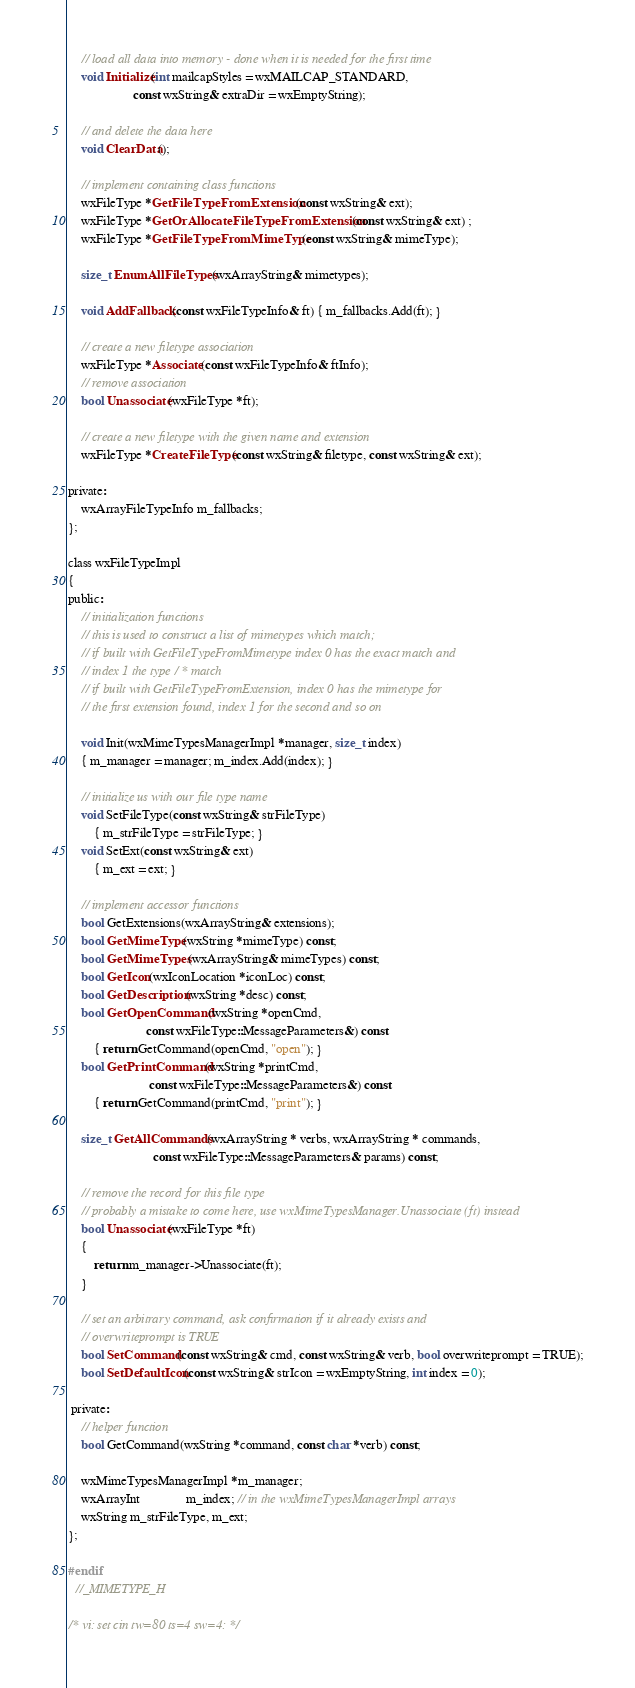<code> <loc_0><loc_0><loc_500><loc_500><_C_>
    // load all data into memory - done when it is needed for the first time
    void Initialize(int mailcapStyles = wxMAILCAP_STANDARD,
                    const wxString& extraDir = wxEmptyString);

    // and delete the data here
    void ClearData();

    // implement containing class functions
    wxFileType *GetFileTypeFromExtension(const wxString& ext);
    wxFileType *GetOrAllocateFileTypeFromExtension(const wxString& ext) ;
    wxFileType *GetFileTypeFromMimeType(const wxString& mimeType);

    size_t EnumAllFileTypes(wxArrayString& mimetypes);

    void AddFallback(const wxFileTypeInfo& ft) { m_fallbacks.Add(ft); }

    // create a new filetype association
    wxFileType *Associate(const wxFileTypeInfo& ftInfo);
    // remove association
    bool Unassociate(wxFileType *ft);

    // create a new filetype with the given name and extension
    wxFileType *CreateFileType(const wxString& filetype, const wxString& ext);

private:
    wxArrayFileTypeInfo m_fallbacks;
};

class wxFileTypeImpl
{
public:
    // initialization functions
    // this is used to construct a list of mimetypes which match;
    // if built with GetFileTypeFromMimetype index 0 has the exact match and
    // index 1 the type / * match
    // if built with GetFileTypeFromExtension, index 0 has the mimetype for
    // the first extension found, index 1 for the second and so on

    void Init(wxMimeTypesManagerImpl *manager, size_t index)
    { m_manager = manager; m_index.Add(index); }

    // initialize us with our file type name
    void SetFileType(const wxString& strFileType)
        { m_strFileType = strFileType; }
    void SetExt(const wxString& ext)
        { m_ext = ext; }

    // implement accessor functions
    bool GetExtensions(wxArrayString& extensions);
    bool GetMimeType(wxString *mimeType) const;
    bool GetMimeTypes(wxArrayString& mimeTypes) const;
    bool GetIcon(wxIconLocation *iconLoc) const;
    bool GetDescription(wxString *desc) const;
    bool GetOpenCommand(wxString *openCmd,
                        const wxFileType::MessageParameters&) const
        { return GetCommand(openCmd, "open"); }
    bool GetPrintCommand(wxString *printCmd,
                         const wxFileType::MessageParameters&) const
        { return GetCommand(printCmd, "print"); }

    size_t GetAllCommands(wxArrayString * verbs, wxArrayString * commands,
                          const wxFileType::MessageParameters& params) const;

    // remove the record for this file type
    // probably a mistake to come here, use wxMimeTypesManager.Unassociate (ft) instead
    bool Unassociate(wxFileType *ft)
    {
        return m_manager->Unassociate(ft);
    }

    // set an arbitrary command, ask confirmation if it already exists and
    // overwriteprompt is TRUE
    bool SetCommand(const wxString& cmd, const wxString& verb, bool overwriteprompt = TRUE);
    bool SetDefaultIcon(const wxString& strIcon = wxEmptyString, int index = 0);

 private:
    // helper function
    bool GetCommand(wxString *command, const char *verb) const;

    wxMimeTypesManagerImpl *m_manager;
    wxArrayInt              m_index; // in the wxMimeTypesManagerImpl arrays
    wxString m_strFileType, m_ext;
};

#endif
  //_MIMETYPE_H

/* vi: set cin tw=80 ts=4 sw=4: */
</code> 